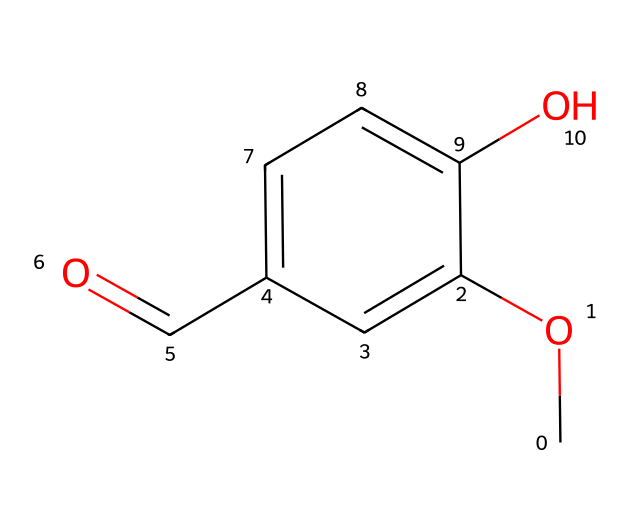What is the name of this chemical? The SMILES representation indicates that this molecule is vanillin, which is known for its vanilla flavor. The presence of the methoxy group and aldehyde functional group characterizes it as vanillin.
Answer: vanillin How many carbon atoms are in the molecule? By analyzing the SMILES structure, we can count the number of carbon atoms represented. The structure shows a total of 8 carbon atoms.
Answer: 8 What functional groups are present in this molecule? The SMILES representation includes a methoxy group (–OCH3) and an aldehyde group (–CHO), which are both functional groups that contribute to the properties and flavor of vanillin.
Answer: methoxy, aldehyde What type of compound is vanillin? Vanillin is classified as an aromatic compound due to the presence of a benzene ring in its structure. The aromatic nature affects the flavor and scent characteristics.
Answer: aromatic How many hydroxyl (–OH) groups are there in this molecule? Looking at the SMILES structure, there is one hydroxyl group (–OH) present in the molecular structure of vanillin, which contributes to its solubility and reactivity.
Answer: 1 Explain why this molecule has a vanilla flavor? The structure of vanillin includes specific functional groups, particularly the methoxy and aldehyde groups, which interact with taste receptors to produce the characteristic vanilla flavor. The aromatic benzene ring also enhances its flavor profile.
Answer: functional groups interact with taste receptors Is vanillin a cage compound? Vanillin is not classified as a cage compound; it has a linear structure with aromatic qualities rather than the complex three-dimensional shape typical of cage compounds.
Answer: no 